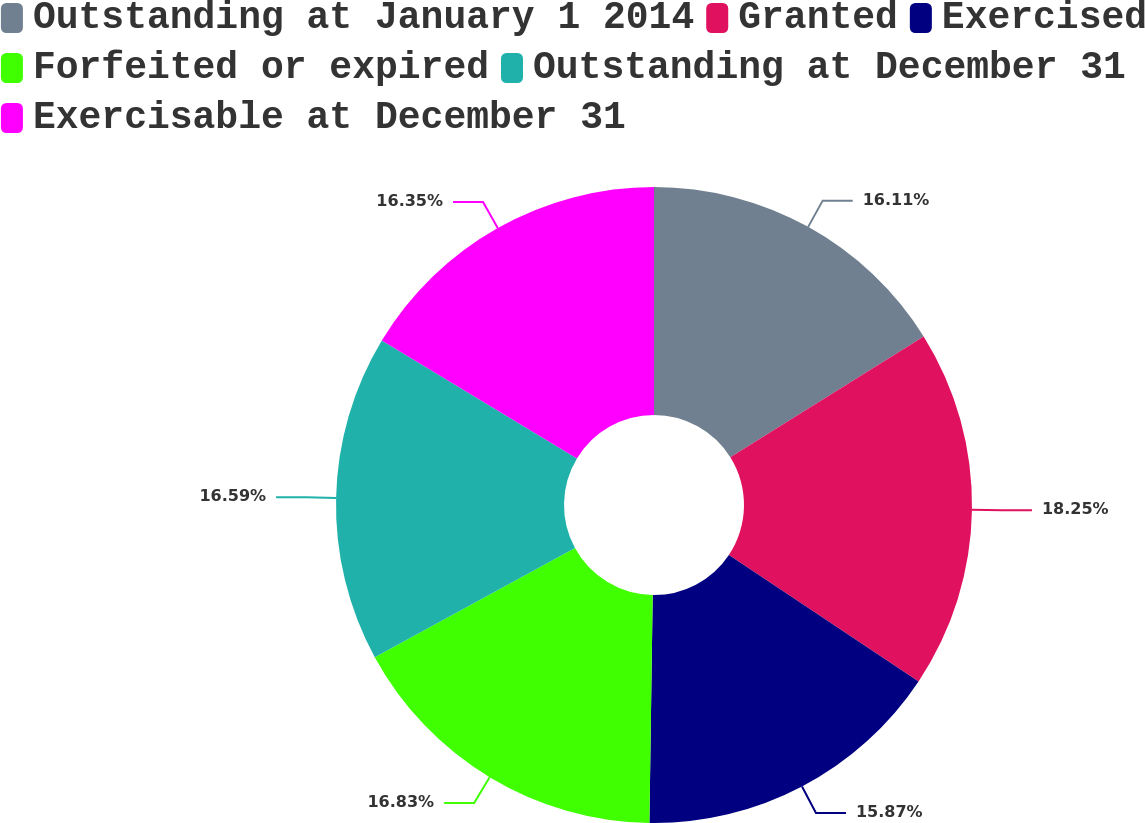<chart> <loc_0><loc_0><loc_500><loc_500><pie_chart><fcel>Outstanding at January 1 2014<fcel>Granted<fcel>Exercised<fcel>Forfeited or expired<fcel>Outstanding at December 31<fcel>Exercisable at December 31<nl><fcel>16.11%<fcel>18.25%<fcel>15.87%<fcel>16.83%<fcel>16.59%<fcel>16.35%<nl></chart> 